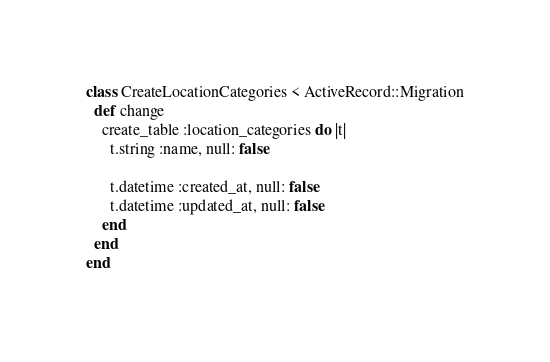<code> <loc_0><loc_0><loc_500><loc_500><_Ruby_>class CreateLocationCategories < ActiveRecord::Migration
  def change
    create_table :location_categories do |t|
      t.string :name, null: false

      t.datetime :created_at, null: false
      t.datetime :updated_at, null: false
    end
  end
end
</code> 